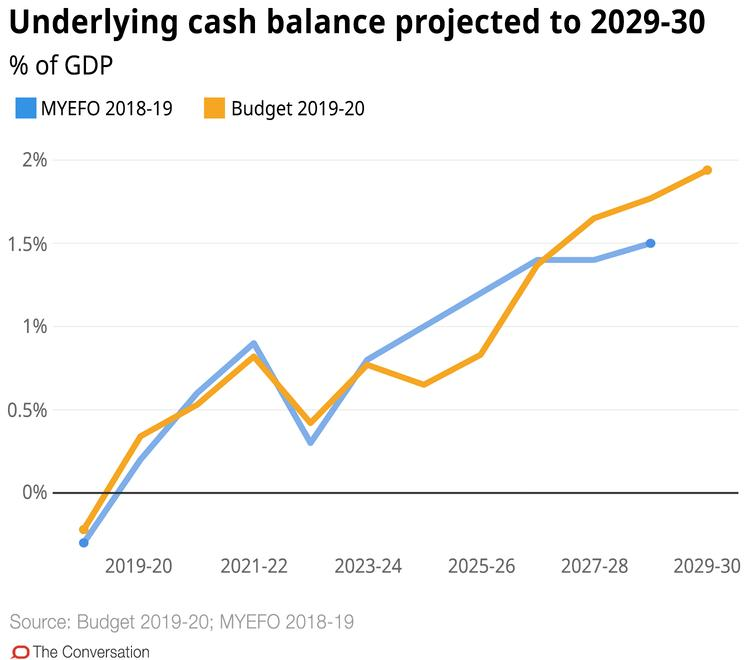List a handful of essential elements in this visual. The orange line in the Budget 2019-20 signifies a significant investment in various sectors, including infrastructure, education, and healthcare. The underlying cash balance for the Budget 2019-20 is expected to be highest in the year 2029-30. According to the MYEFO 2018-19, the line corresponding to the color orange, blue, or red is blue. 